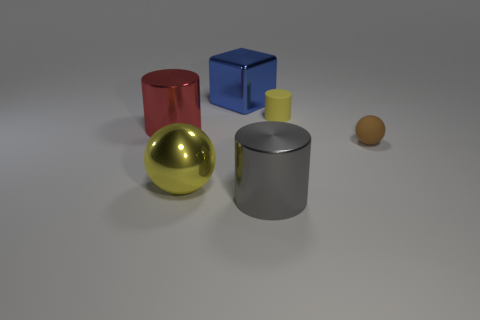The object that is both behind the large gray metallic object and in front of the small sphere is made of what material?
Ensure brevity in your answer.  Metal. Is the color of the big ball the same as the cylinder that is on the right side of the large gray object?
Your answer should be very brief. Yes. There is a yellow thing that is the same size as the red shiny cylinder; what is its material?
Give a very brief answer. Metal. Is there a block that has the same material as the large gray object?
Give a very brief answer. Yes. How many yellow blocks are there?
Make the answer very short. 0. Does the red thing have the same material as the yellow object that is on the left side of the yellow matte cylinder?
Ensure brevity in your answer.  Yes. There is a object that is the same color as the small cylinder; what material is it?
Your response must be concise. Metal. What number of things have the same color as the metallic sphere?
Provide a succinct answer. 1. How big is the gray metal cylinder?
Ensure brevity in your answer.  Large. There is a red object; does it have the same shape as the tiny object that is on the right side of the small cylinder?
Keep it short and to the point. No. 